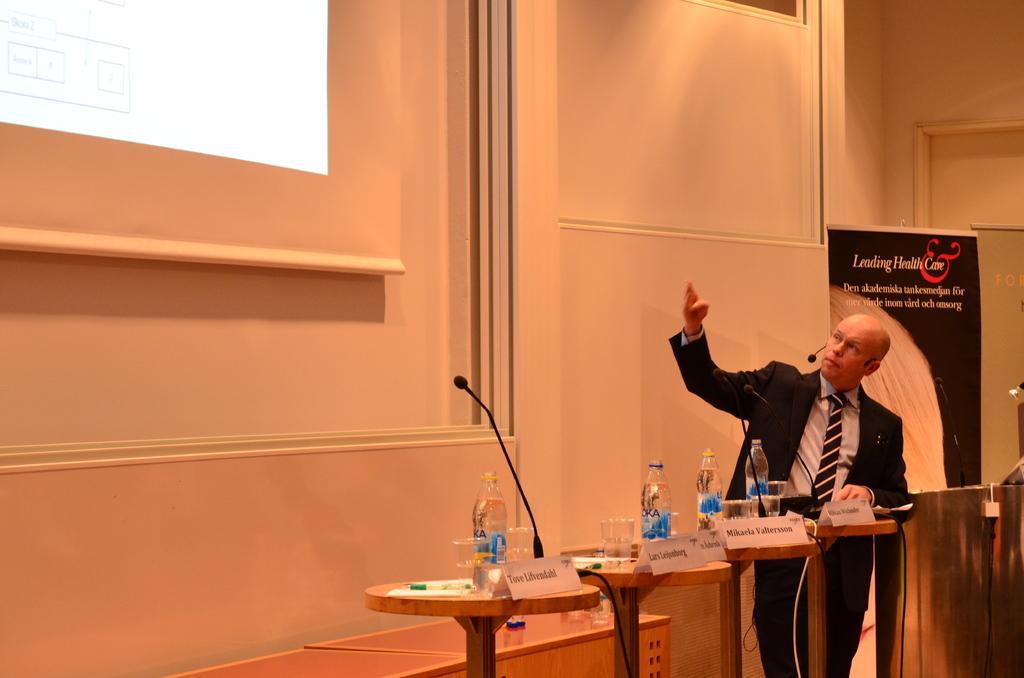Can you describe this image briefly? In this image we can see a person standing. Beside the person we can see a podium and few tables on which there are few objects. Behind the person we can see a banner and a wall. In the top left, we can see a presentation which consists of some text. 